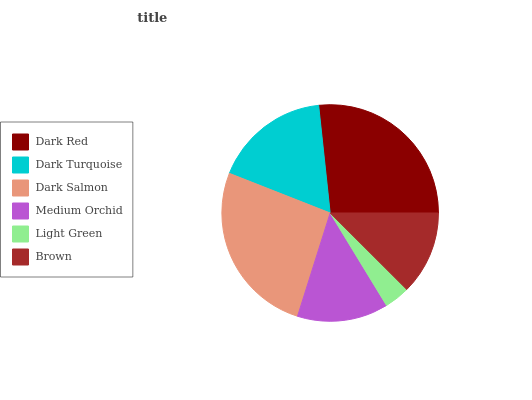Is Light Green the minimum?
Answer yes or no. Yes. Is Dark Red the maximum?
Answer yes or no. Yes. Is Dark Turquoise the minimum?
Answer yes or no. No. Is Dark Turquoise the maximum?
Answer yes or no. No. Is Dark Red greater than Dark Turquoise?
Answer yes or no. Yes. Is Dark Turquoise less than Dark Red?
Answer yes or no. Yes. Is Dark Turquoise greater than Dark Red?
Answer yes or no. No. Is Dark Red less than Dark Turquoise?
Answer yes or no. No. Is Dark Turquoise the high median?
Answer yes or no. Yes. Is Medium Orchid the low median?
Answer yes or no. Yes. Is Dark Red the high median?
Answer yes or no. No. Is Brown the low median?
Answer yes or no. No. 